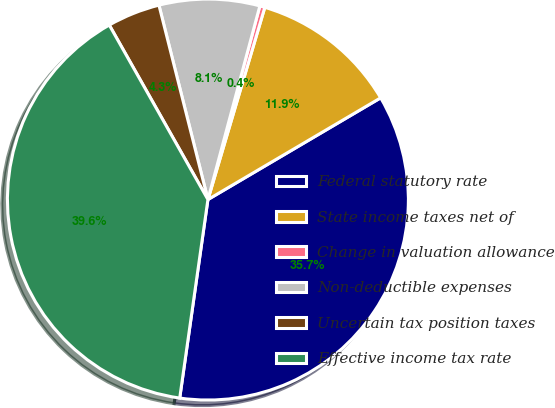Convert chart to OTSL. <chart><loc_0><loc_0><loc_500><loc_500><pie_chart><fcel>Federal statutory rate<fcel>State income taxes net of<fcel>Change in valuation allowance<fcel>Non-deductible expenses<fcel>Uncertain tax position taxes<fcel>Effective income tax rate<nl><fcel>35.72%<fcel>11.95%<fcel>0.41%<fcel>8.1%<fcel>4.26%<fcel>39.57%<nl></chart> 